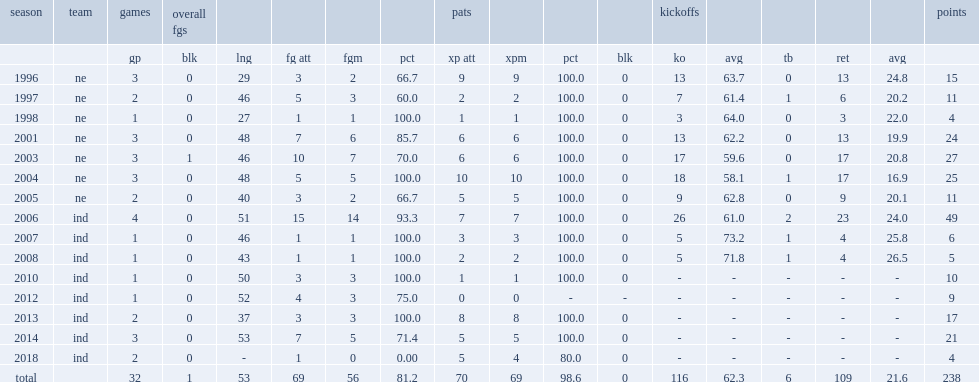How many points did adam vinatieri score in the postseason? 238.0. 